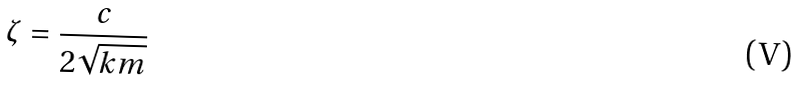Convert formula to latex. <formula><loc_0><loc_0><loc_500><loc_500>\zeta = \frac { c } { 2 \sqrt { k m } }</formula> 